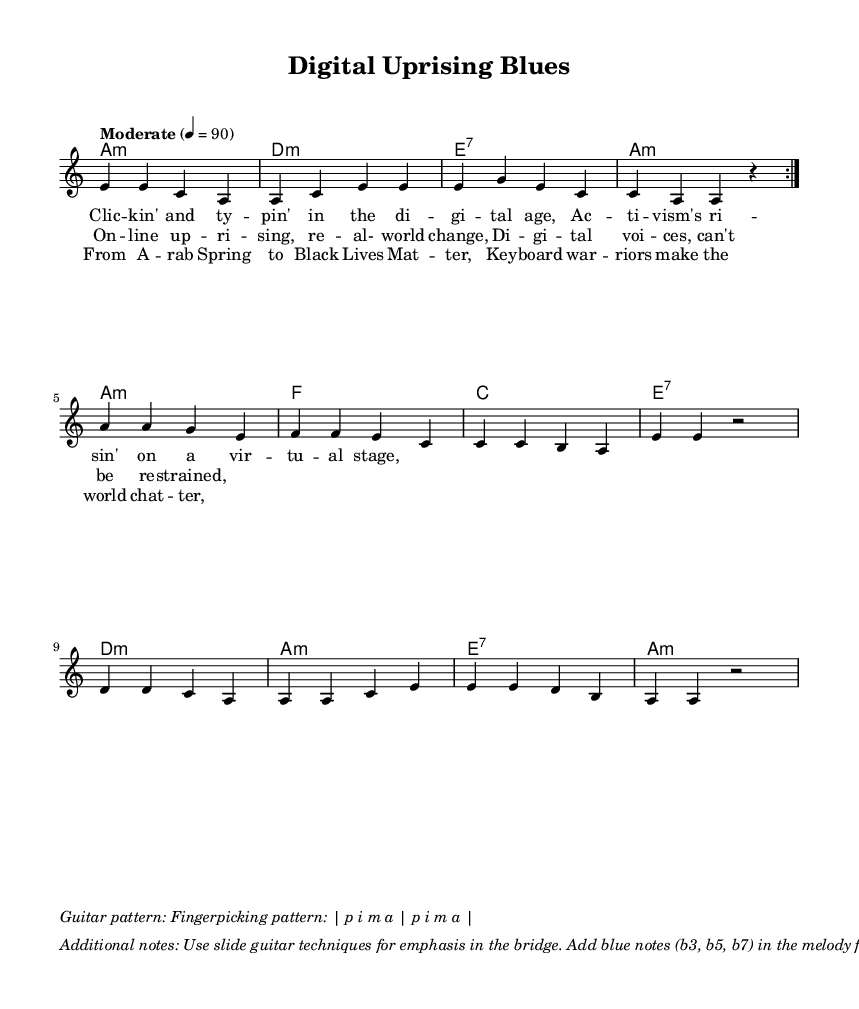What is the key signature of this music? The key signature indicates the piece is in A minor, which has no sharps or flats. This can be deduced from the key indication at the beginning of the score.
Answer: A minor What is the time signature of this music? The time signature is 4/4, which means there are four beats in a measure. This can be found at the start of the score alongside the key signature.
Answer: 4/4 What is the tempo marking for this piece? The tempo marking indicates "Moderate" with a metronome marking of 90 beats per minute, specified clearly at the beginning of the score.
Answer: Moderate 4 = 90 How many sections are present in the song structure? The song structure consists of a verse, chorus, and bridge, which can be identified by the distinct lyrics sections labeled accordingly in the score.
Answer: Three What specific blues elements are present in this piece? The piece incorporates fingerpicking patterns and blue notes, specifically the flattened third, fifth, and seventh notes, typical of the blues genre, as outlined in the additional notes.
Answer: Fingerpicking and blue notes What notable historical references are made in the lyrics? The lyrics reference "Arab Spring" and "Black Lives Matter," indicating significant social movements and online activism's impact, which can be inferred from the context of the bridge section.
Answer: Arab Spring and Black Lives Matter 